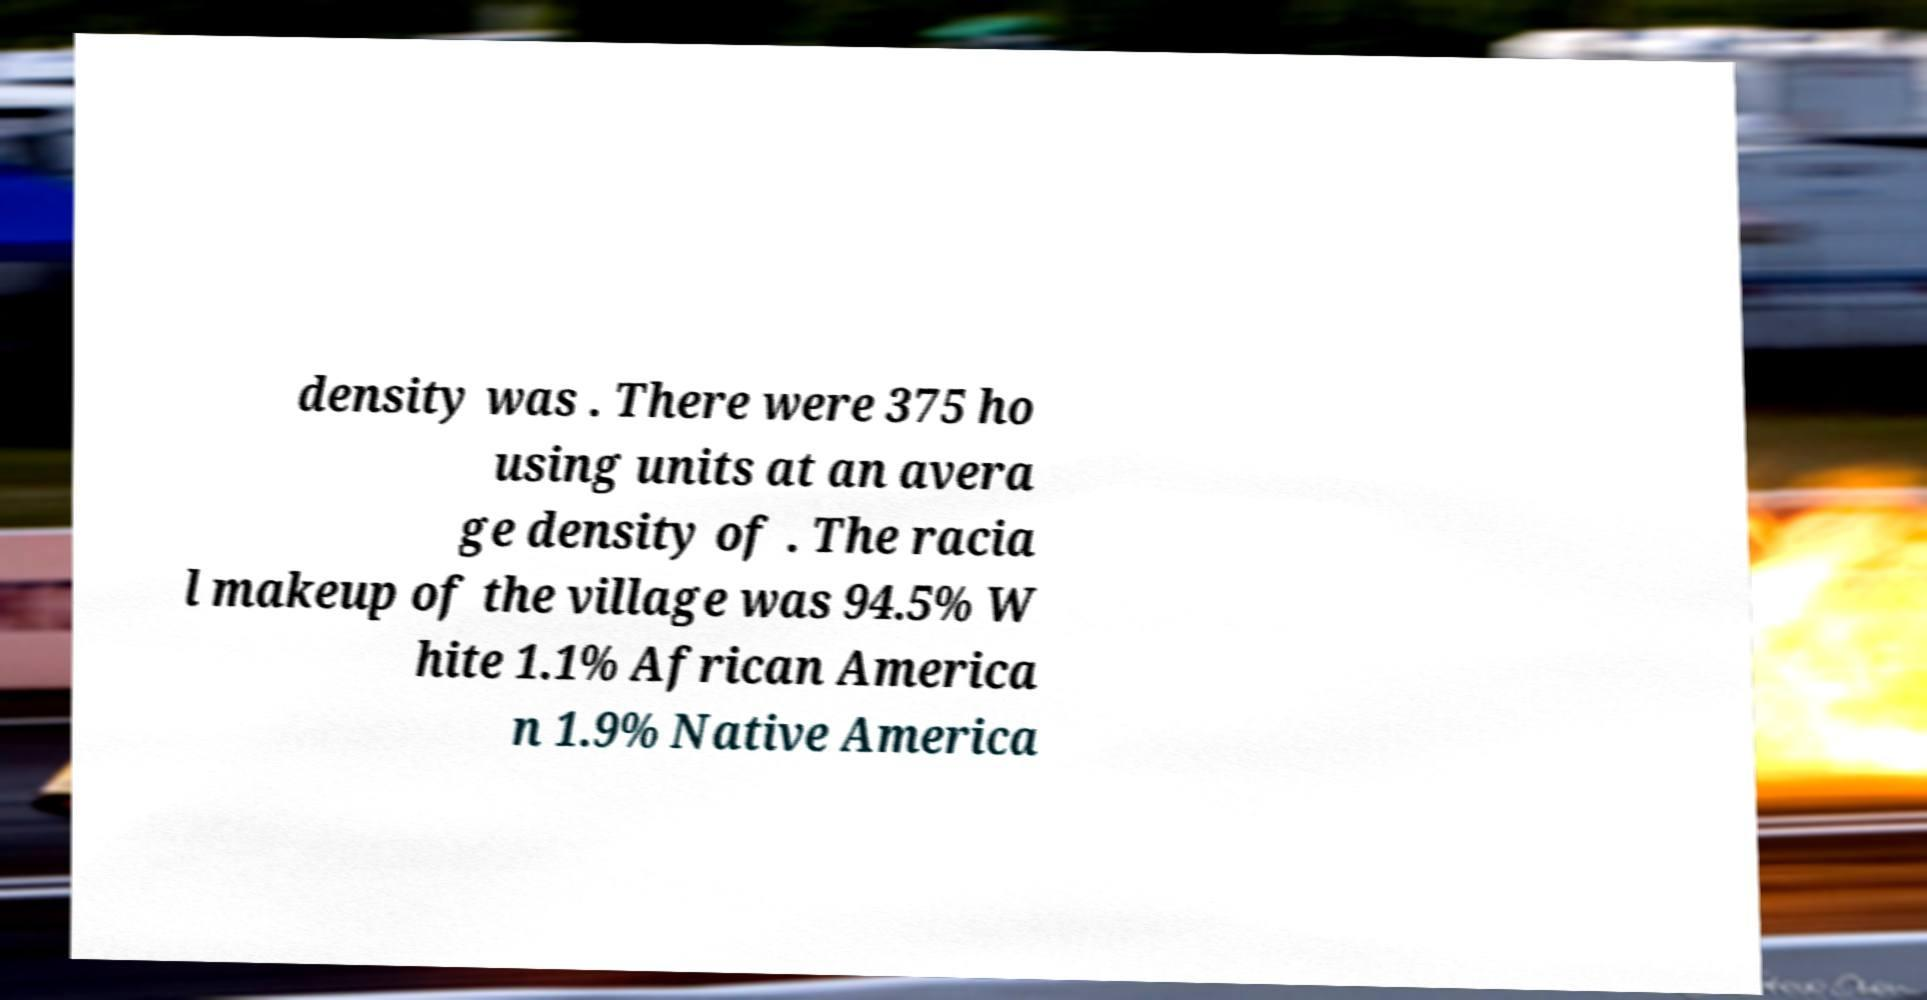I need the written content from this picture converted into text. Can you do that? density was . There were 375 ho using units at an avera ge density of . The racia l makeup of the village was 94.5% W hite 1.1% African America n 1.9% Native America 